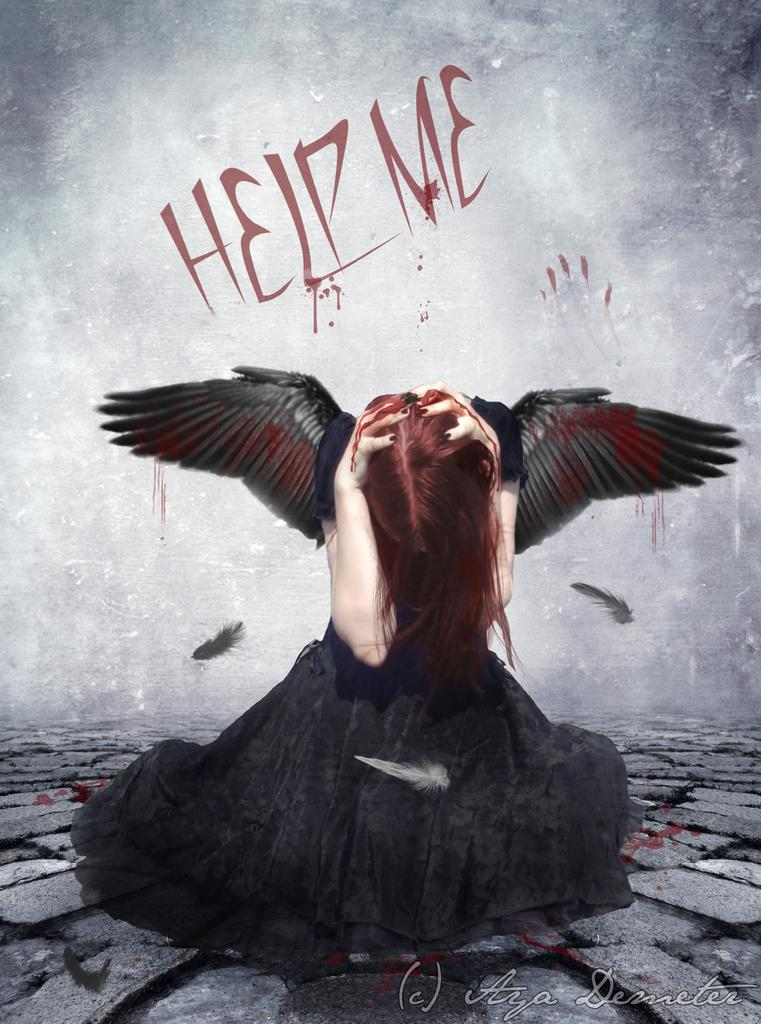What is the main subject in the middle of the image? There is a bird in the middle of the image. What can be seen in the background of the image? There is a wall in the background of the image. What is the color scheme of the wall? The wall is in black and white color. What type of surface is visible at the bottom of the image? There are stones at the bottom of the image. What type of drum can be heard playing in the background of the image? There is no drum or sound present in the image; it is a still image featuring a bird, a wall, and stones. 